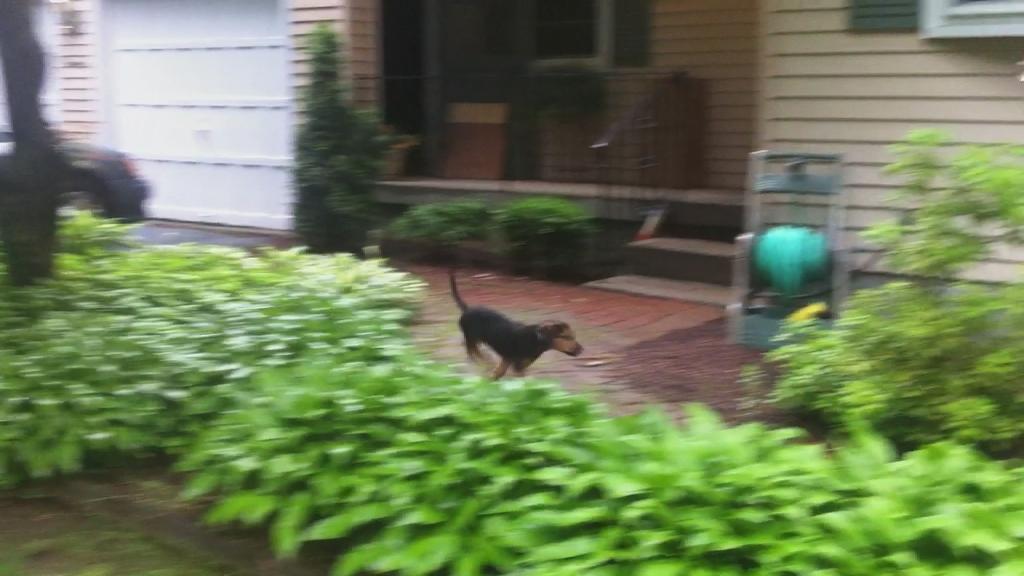Could you give a brief overview of what you see in this image? In this image, we can see plants and there is a dog. In the background, there is a building and we can see some stairs. 